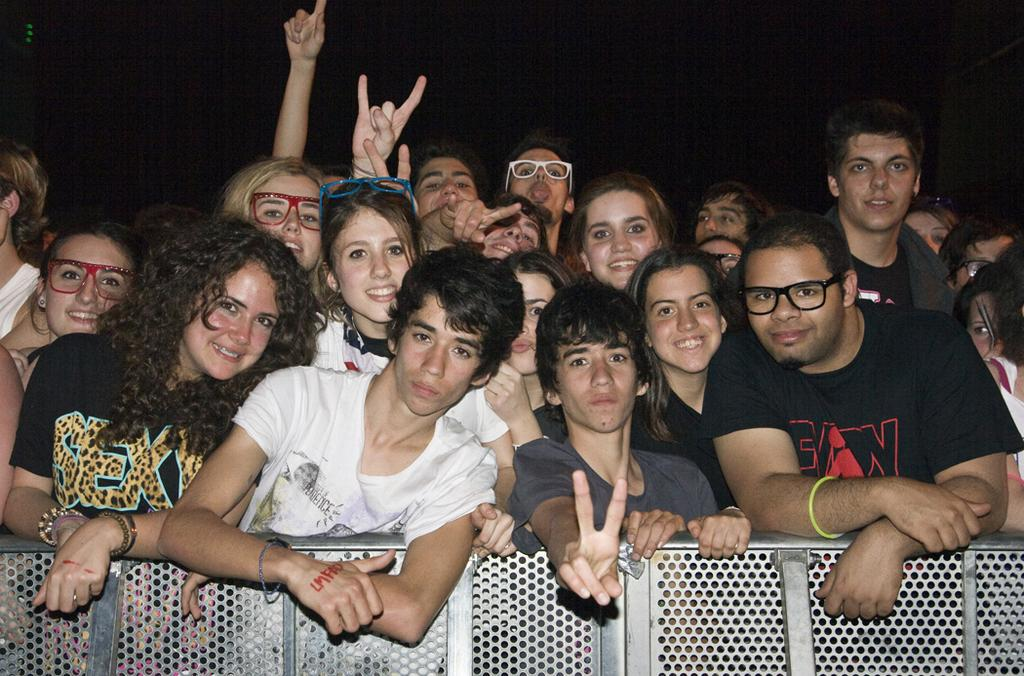What is the main subject of the image? The main subject of the image is persons standing behind a fence. Can you describe the appearance of any specific person in the image? Yes, there is a person wearing spectacles on the right side of the image. Are there any other persons wearing spectacles in the image? Yes, there is a woman wearing spectacles on the left side of the image. What type of cheese is being stored in the jar on the left side of the image? There is no jar or cheese present in the image. 